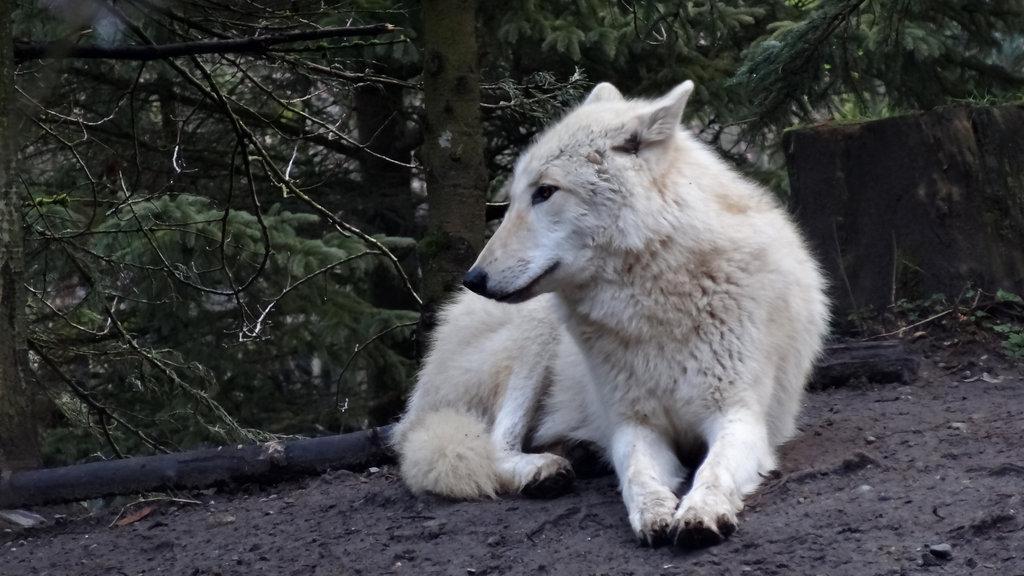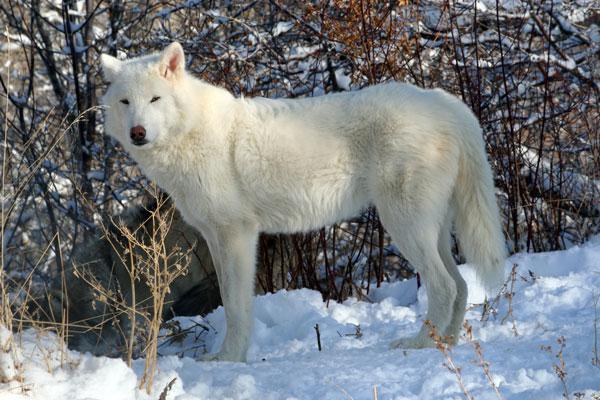The first image is the image on the left, the second image is the image on the right. Given the left and right images, does the statement "An animal is laying down." hold true? Answer yes or no. Yes. The first image is the image on the left, the second image is the image on the right. Given the left and right images, does the statement "A canine can be seen laying on the ground." hold true? Answer yes or no. Yes. 